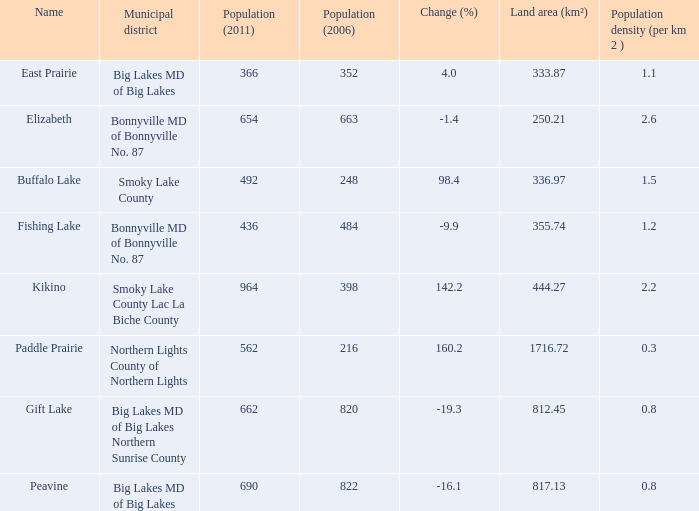What is the density per km in Smoky Lake County? 1.5. 